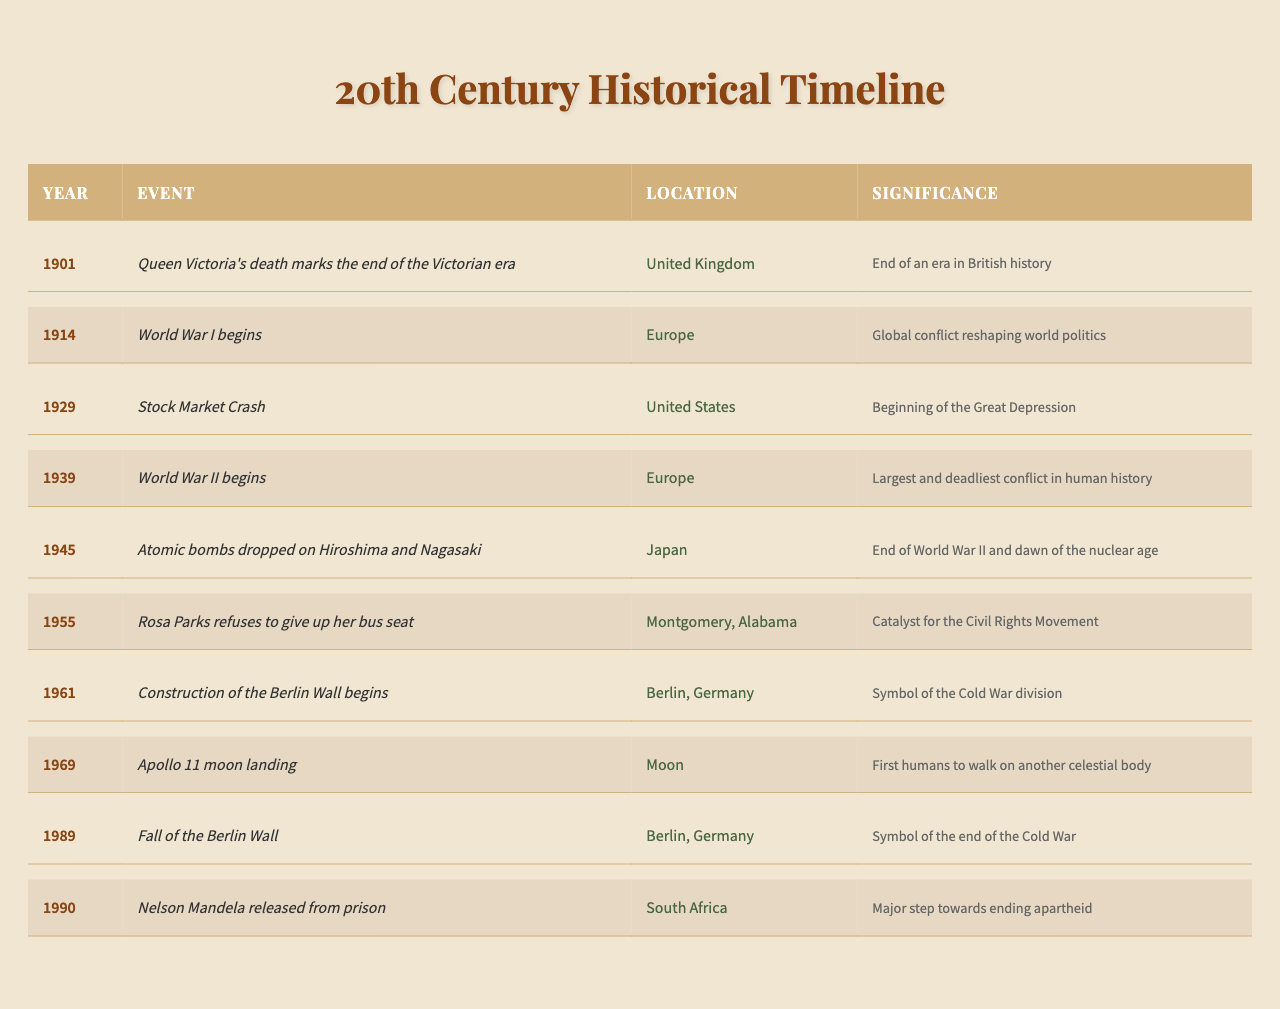What event marked the end of the Victorian era? According to the table, Queen Victoria's death in 1901 marked the end of the Victorian era in the United Kingdom.
Answer: Queen Victoria's death In what year did World War I begin? The table indicates that World War I began in the year 1914.
Answer: 1914 Which event is described as the catalyst for the Civil Rights Movement? The table notes that Rosa Parks refused to give up her bus seat in 1955, which is identified as a catalyst for the Civil Rights Movement.
Answer: Rosa Parks refuses to give up her bus seat How many years are there between the beginning of World War I and the end of World War II? The timeline shows World War I beginning in 1914 and World War II ending in 1945. The difference is 1945 - 1914 = 31 years.
Answer: 31 years True or False: The Atomic bombs were dropped before World War II started. Referring to the table, the atomic bombs were dropped in 1945 after World War II began in 1939, making the statement false.
Answer: False What was the significance of the fall of the Berlin Wall? The table describes the fall of the Berlin Wall in 1989 as a symbol of the end of the Cold War, which indicates its historical significance.
Answer: Symbol of the end of the Cold War List the events that occurred in the United States from 1901 to 1990. The table lists the Stock Market Crash in 1929 and Rosa Parks' refusal in 1955 as events that occurred in the United States during this timeframe. These are the only two entries from the U.S.
Answer: Stock Market Crash in 1929 and Rosa Parks refuses to give up her bus seat in 1955 Count the total number of events listed in the table. The table presents a total of 10 distinct historical events, with each entry representing a unique occurrence.
Answer: 10 events Which event occurred between the launch of the Apollo 11 moon landing and the release of Nelson Mandela from prison? The table shows the Apollo 11 moon landing took place in 1969 and Nelson Mandela was released in 1990, while the fall of the Berlin Wall occurred in 1989. Thus, the Berlin Wall's fall is the event that fits this criterion.
Answer: Fall of the Berlin Wall Identify the last major event listed in the table and its significance. The last major event in the table is Nelson Mandela being released from prison in 1990, which is noted as a significant step toward ending apartheid in South Africa.
Answer: Nelson Mandela released from prison, significant step towards ending apartheid 